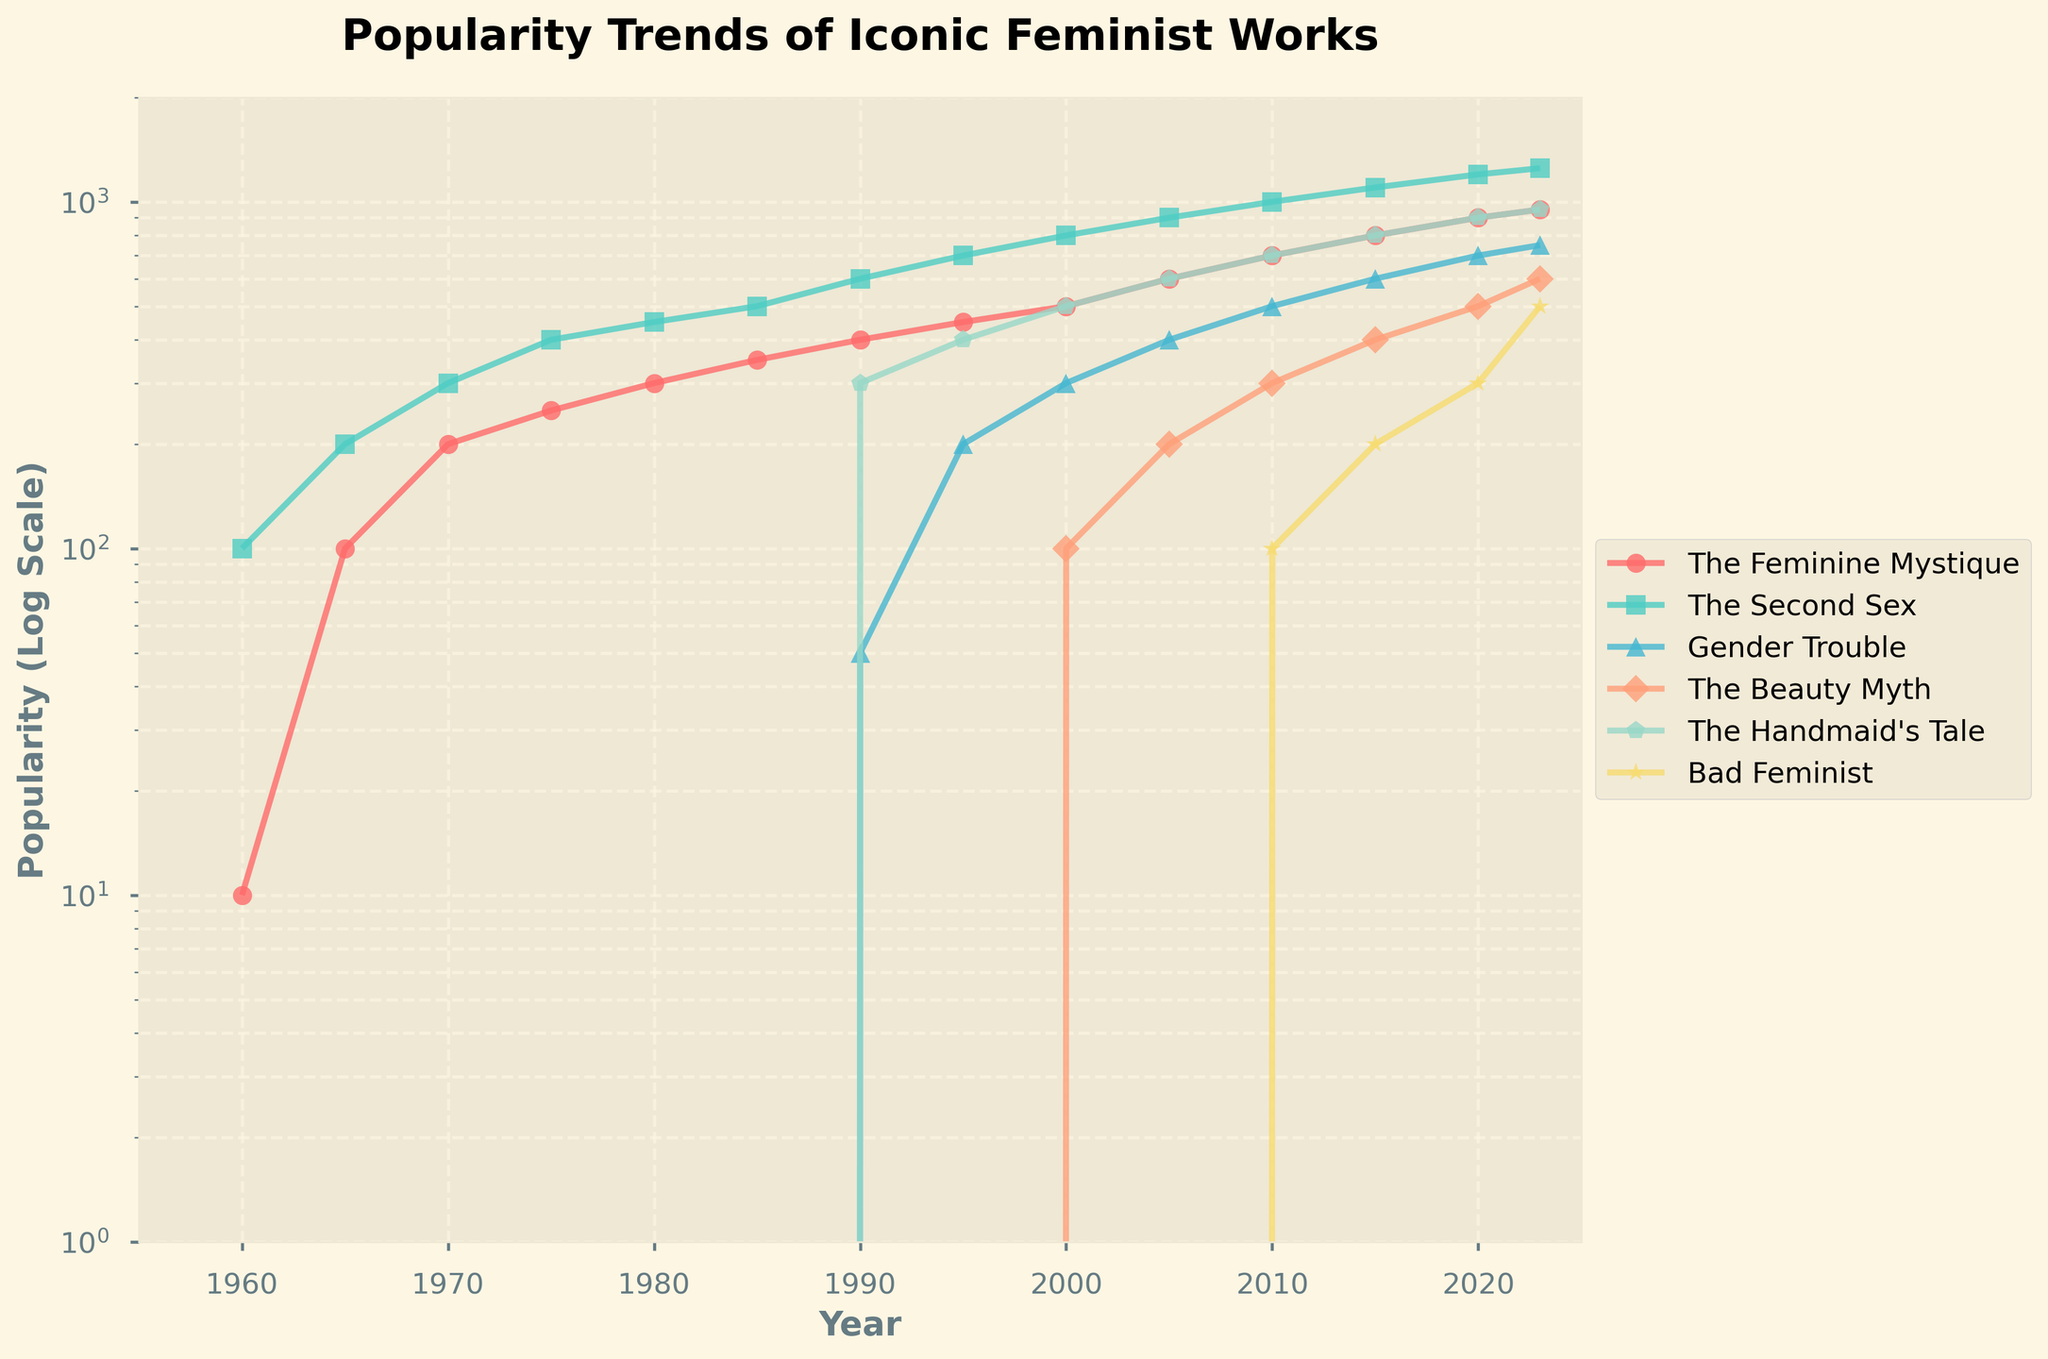what are the years of maximum popularity for each work? To find the years of maximum popularity, look at the highest points for each line in the plot. For 'The Feminine Mystique,' 'The Second Sex,' 'Gender Trouble,' 'The Beauty Myth,' 'The Handmaid's Tale,' and 'Bad Feminist,' their maximum points are in 2023.
Answer: 2023 which work had the highest popularity in 1990? To determine which work had the highest popularity in 1990, compare the points on the Y-axis for each work in the year 1990. 'The Second Sex' has the highest value (600) at that time.
Answer: The Second Sex how did the popularity of 'The Beauty Myth' change between 2000 and 2010? To evaluate the change in popularity, compare the Y-axis values for 'The Beauty Myth' between 2000 and 2010. In 2000, it was 100, and in 2010, it was 300, showing an increase of 200 units.
Answer: Increased by 200 which work shows the steepest growth trend between 1960 and 2023? To determine the steepest growth, look at the slope of each line between 1960 and 2023. 'The Second Sex' shows the sharpest rise, going from 100 to 1250 over the period.
Answer: The Second Sex what is the general trend in the popularity of 'Bad Feminist'? Examine the trendline for 'Bad Feminist' from the year it appears (2010) to 2023. Its popularity consistently increases from 100 in 2010 to 500 in 2023.
Answer: Increasing how many works have their data points aligned on the log scale Y-axis between 100 and 200 in the year 2023? To find the count, locate the data points for each work on the Y-axis for 2023 and check which ones fall between 100 and 200. 'Bad Feminist' is the only work meeting this criterion.
Answer: 1 which works had no recorded popularity in 2000? Check the Y-axis values for each work in the year 2000. 'Gender Trouble' and 'Bad Feminist' show no recorded data (0) in that year.
Answer: Gender Trouble, Bad Feminist what is the average popularity of 'The Handmaid's Tale' between 1985 and 2005? Calculate the average by taking the values for 'The Handmaid's Tale' from 1985 (0) to 2005 (600), then sum these values (300+400) and divide by the number of data points (2).
Answer: 450 which work shows the least change in popularity between 1960 and 1985? Compare the differences in Y-axis values for each work between 1960 and 1985. 'The Feminine Mystique' changes from 10 to 350, and 'The Second Sex' changes from 100 to 500. 'The Second Sex' shows the least change.
Answer: The Feminine Mystique 